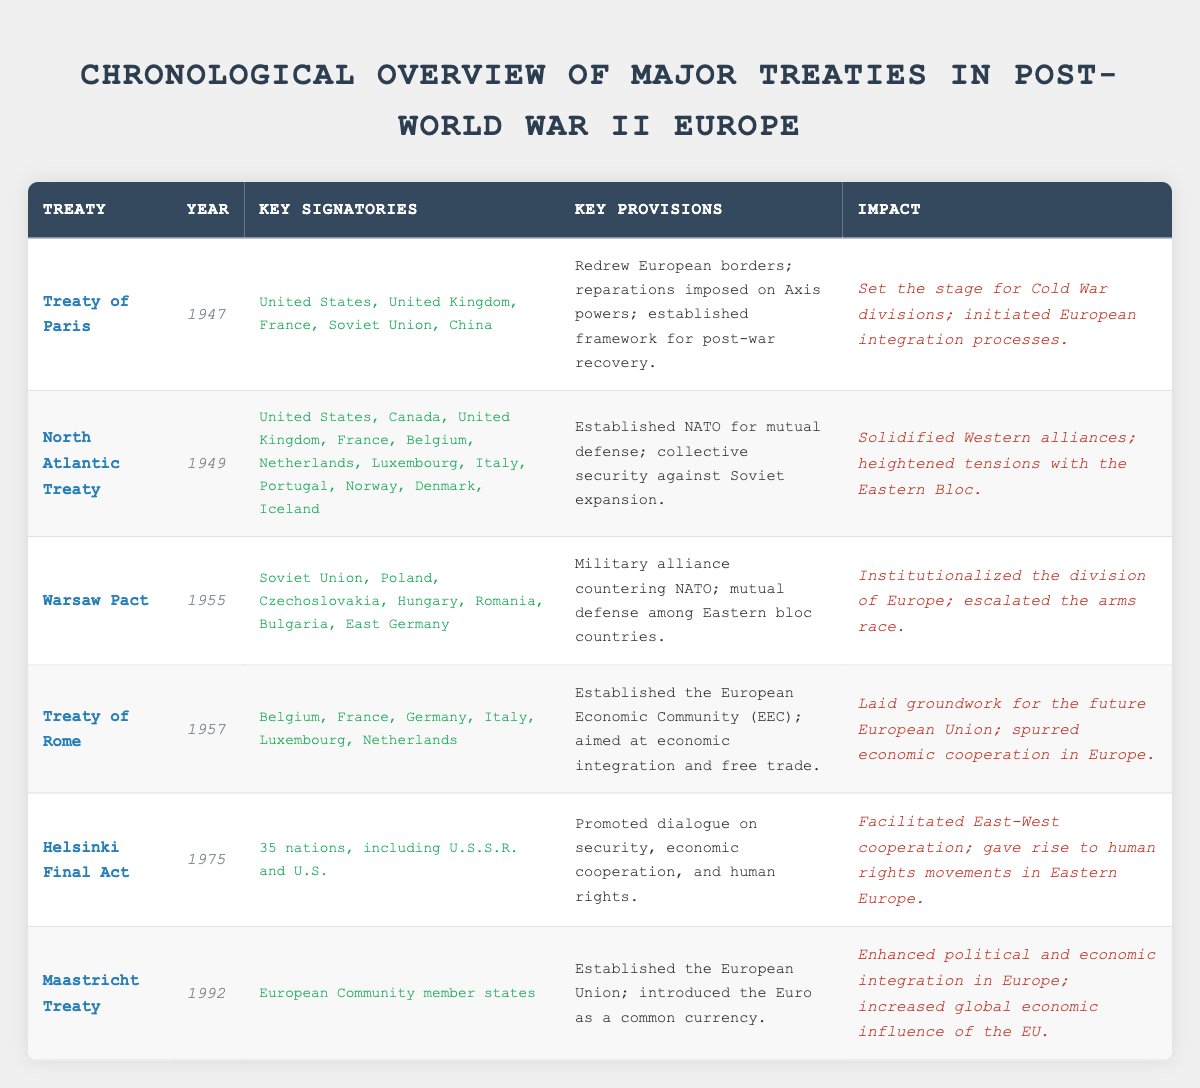What is the year of the Maastricht Treaty? The Maastricht Treaty is listed in the table under the "Year" column. It states "1992" as the year it was signed.
Answer: 1992 Which treaty was signed in 1955 and what was its impact? Referring to the entry for the Warsaw Pact in the table, it was signed in 1955. The impact noted is that it institutionalized the division of Europe and escalated the arms race.
Answer: Warsaw Pact; Institutionalized the division of Europe; escalated the arms race How many nations were signatories of the Helsinki Final Act? The table mentions that the Helsinki Final Act was signed by "35 nations, including U.S.S.R. and U.S." This specifies the exact amount of nations.
Answer: 35 Did the Treaty of Rome contribute to the foundation of the European Union? The entry for the Treaty of Rome notes that it laid the groundwork for the future European Union, indicating a positive contribution.
Answer: Yes Which treaties were established to counter the expansion of Soviet influence? The North Atlantic Treaty was established for mutual defense against Soviet expansion and the Warsaw Pact was a military alliance countering NATO, thus both treaties address countering Soviet influence.
Answer: North Atlantic Treaty; Warsaw Pact What key provision was common in both the North Atlantic Treaty and the Warsaw Pact? Both treaties emphasized mutual defense among their respective member states, as stated in the provisions for each.
Answer: Mutual defense What is the difference in years between the signing of the Helsinki Final Act and the Treaty of Paris? The Helsinki Final Act was signed in 1975 and the Treaty of Paris in 1947. The difference is calculated as 1975 - 1947 = 28 years.
Answer: 28 years Which treaty established NATO and what year was it signed? The North Atlantic Treaty established NATO and was signed in the year 1949, as indicated in the table.
Answer: North Atlantic Treaty; 1949 List the key provisions of the Treaty of Rome and the Maastricht Treaty. The Treaty of Rome’s key provisions include establishing the European Economic Community aimed at economic integration and free trade. The Maastricht Treaty established the European Union and introduced the Euro.
Answer: EEC establishment; Economic integration and free trade; EU establishment; Introduction of Euro 